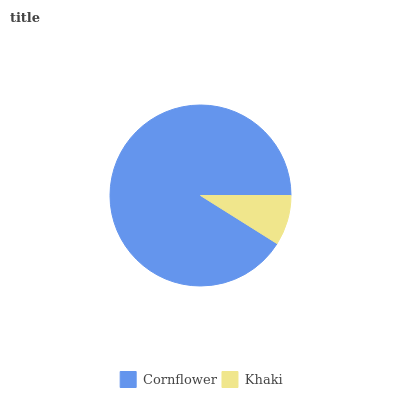Is Khaki the minimum?
Answer yes or no. Yes. Is Cornflower the maximum?
Answer yes or no. Yes. Is Khaki the maximum?
Answer yes or no. No. Is Cornflower greater than Khaki?
Answer yes or no. Yes. Is Khaki less than Cornflower?
Answer yes or no. Yes. Is Khaki greater than Cornflower?
Answer yes or no. No. Is Cornflower less than Khaki?
Answer yes or no. No. Is Cornflower the high median?
Answer yes or no. Yes. Is Khaki the low median?
Answer yes or no. Yes. Is Khaki the high median?
Answer yes or no. No. Is Cornflower the low median?
Answer yes or no. No. 